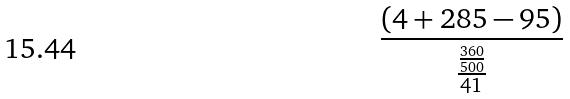<formula> <loc_0><loc_0><loc_500><loc_500>\frac { ( 4 + 2 8 5 - 9 5 ) } { \frac { \frac { 3 6 0 } { 5 0 0 } } { 4 1 } }</formula> 